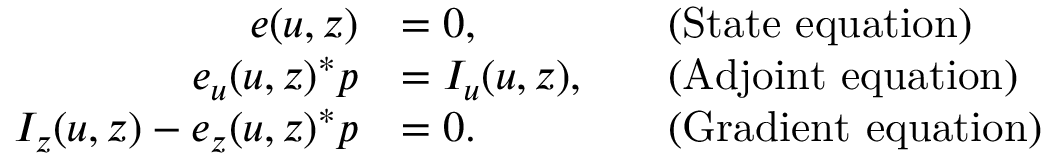Convert formula to latex. <formula><loc_0><loc_0><loc_500><loc_500>\begin{array} { r l r l } { e ( u , z ) } & { = 0 , } & & { ( S t a t e e q u a t i o n ) } \\ { e _ { u } ( u , z ) ^ { * } p } & { = I _ { u } ( u , z ) , } & & { ( A d j o i n t e q u a t i o n ) } \\ { I _ { z } ( u , z ) - e _ { z } ( u , z ) ^ { * } p } & { = 0 . } & & { ( G r a d i e n t e q u a t i o n ) } \end{array}</formula> 